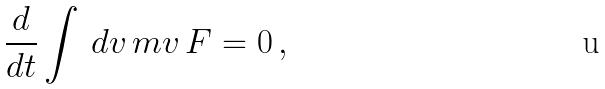<formula> <loc_0><loc_0><loc_500><loc_500>\frac { d } { d t } \int \, d v \, m v \, F = 0 \, ,</formula> 